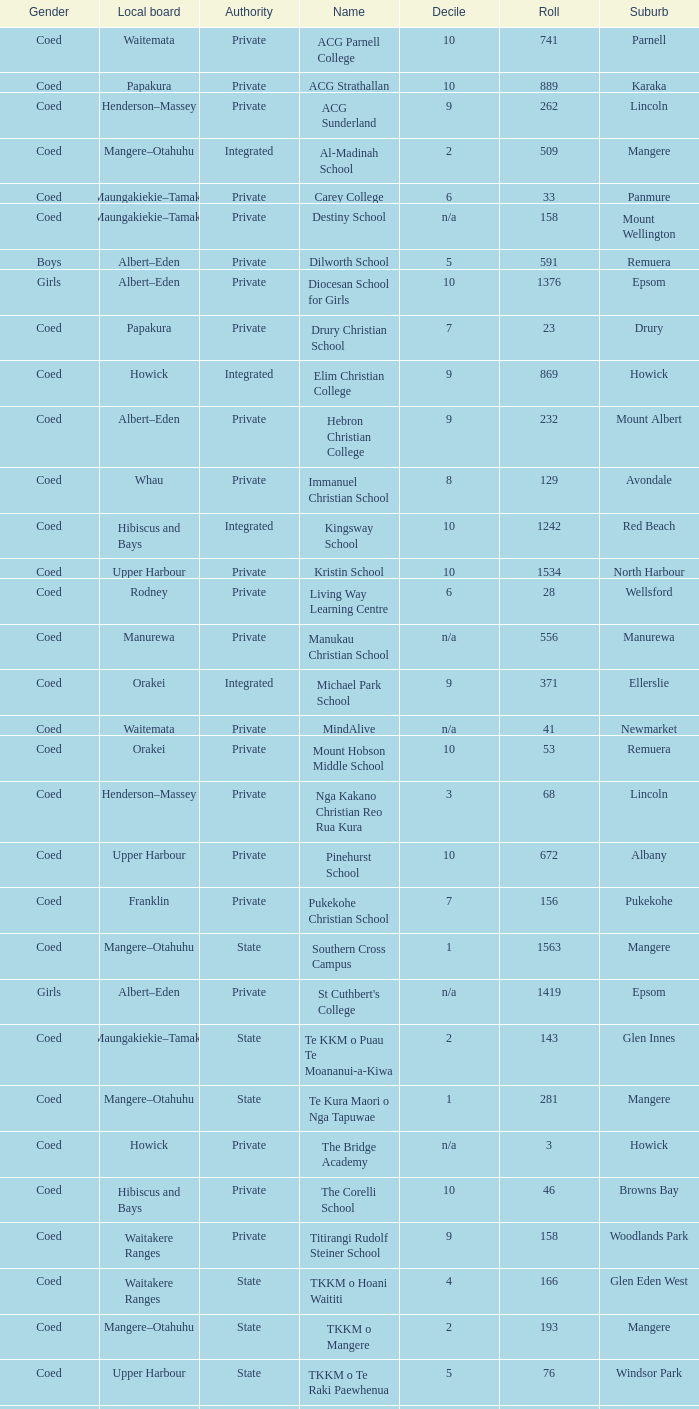What gender has a local board of albert–eden with a roll of more than 232 and Decile of 5? Boys. 